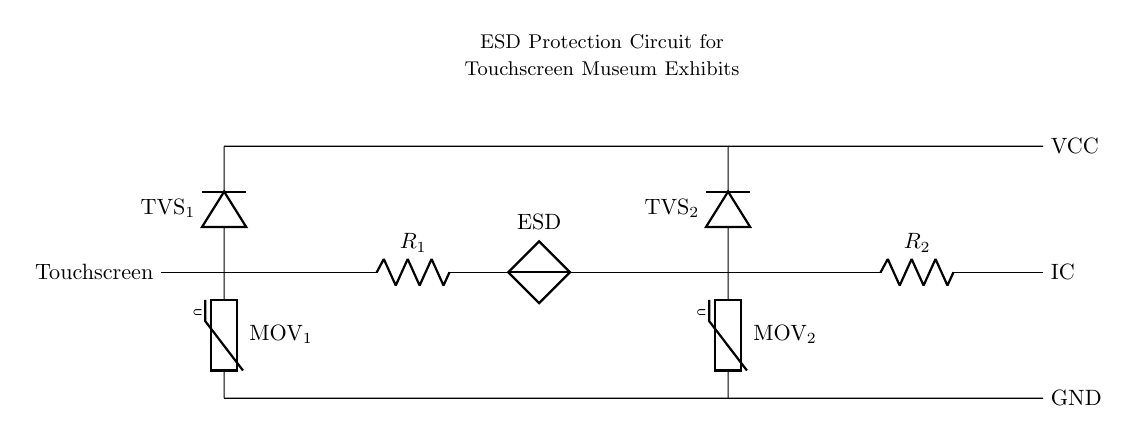What components are used for ESD protection in this circuit? The circuit utilizes two Metal Oxide Varistors (MOV) and two Transient Voltage Suppressors (TVS) to protect against ESD.
Answer: MOV and TVS What is the value of resistor R1? The diagram does not specify a numerical value for R1, but indicates that it is part of the circuit which contributes to current limiting.
Answer: Not specified What does the term 'GND' refer to in this circuit? 'GND' represents the ground connection in the circuit, which is the reference point for all voltages in the system.
Answer: Ground How many varistors are present in the circuit? There are two varistors in the circuit, labeled as MOV1 and MOV2, which provide overvoltage protection.
Answer: Two What is the purpose of the TVS components in this circuit? The Transient Voltage Suppressors (TVS) are designed to clamp voltage spikes and protect sensitive components from damage.
Answer: Voltage clamping Which component is connected directly to the touchscreen? The first varistor (MOV1) is connected directly to the touchscreen, providing protection against ESD.
Answer: MOV1 What is the function of resistor R2 in the circuit? R2 is likely involved in current limiting or voltage division, ensuring that the touchscreen receives safe operating conditions.
Answer: Current limiting 